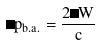<formula> <loc_0><loc_0><loc_500><loc_500>\Delta p _ { b . a . } = \frac { 2 \Delta W } { c }</formula> 